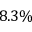<formula> <loc_0><loc_0><loc_500><loc_500>8 . 3 \%</formula> 